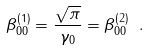<formula> <loc_0><loc_0><loc_500><loc_500>\beta _ { 0 0 } ^ { ( 1 ) } = \frac { \sqrt { \pi } } { \gamma _ { 0 } } = \beta _ { 0 0 } ^ { ( 2 ) } \ .</formula> 